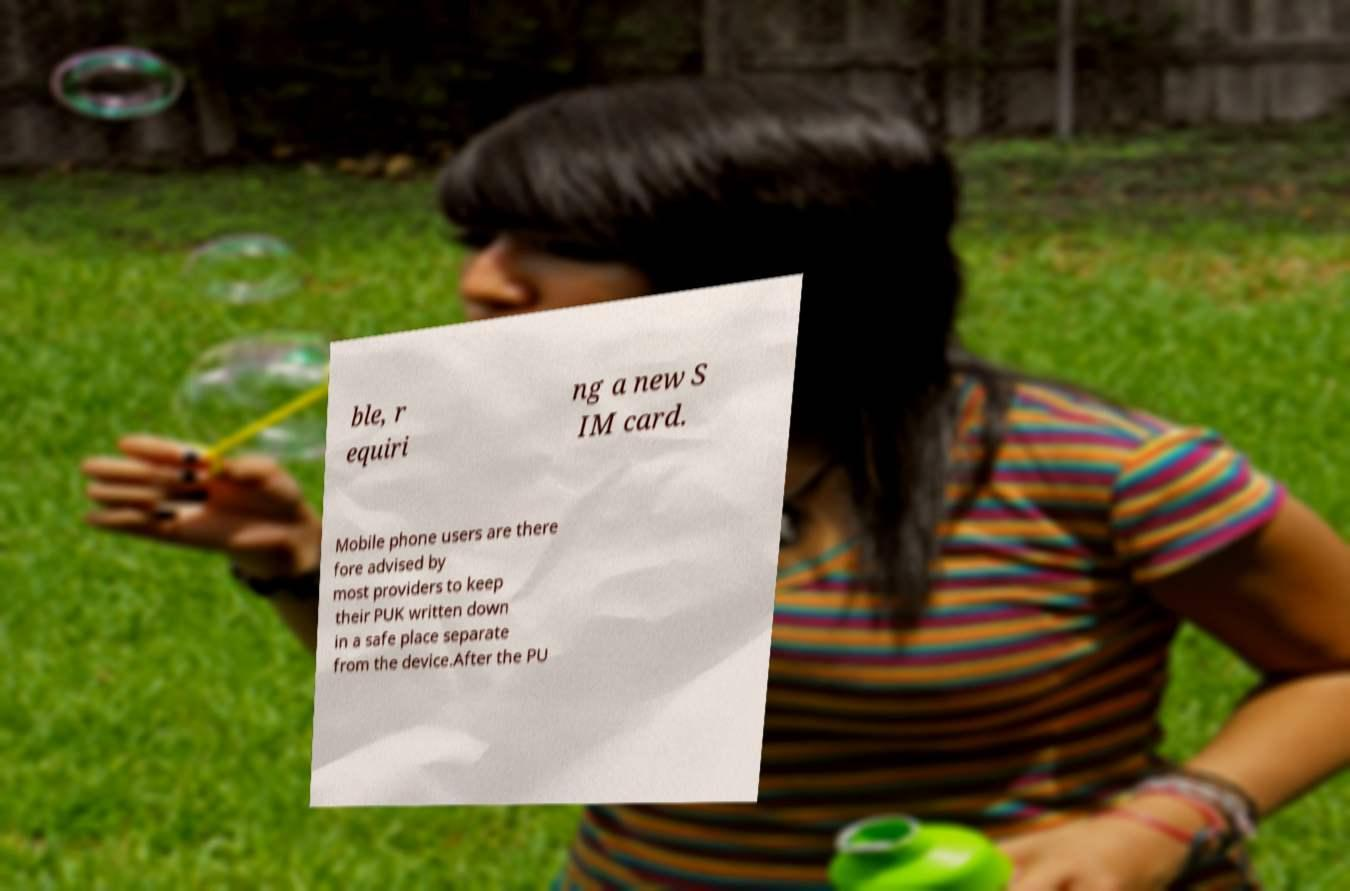There's text embedded in this image that I need extracted. Can you transcribe it verbatim? ble, r equiri ng a new S IM card. Mobile phone users are there fore advised by most providers to keep their PUK written down in a safe place separate from the device.After the PU 